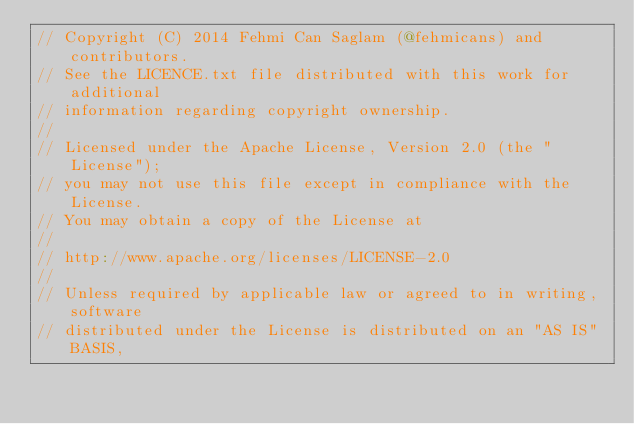<code> <loc_0><loc_0><loc_500><loc_500><_Scala_>// Copyright (C) 2014 Fehmi Can Saglam (@fehmicans) and contributors.
// See the LICENCE.txt file distributed with this work for additional
// information regarding copyright ownership.
//
// Licensed under the Apache License, Version 2.0 (the "License");
// you may not use this file except in compliance with the License.
// You may obtain a copy of the License at
//
// http://www.apache.org/licenses/LICENSE-2.0
//
// Unless required by applicable law or agreed to in writing, software
// distributed under the License is distributed on an "AS IS" BASIS,</code> 